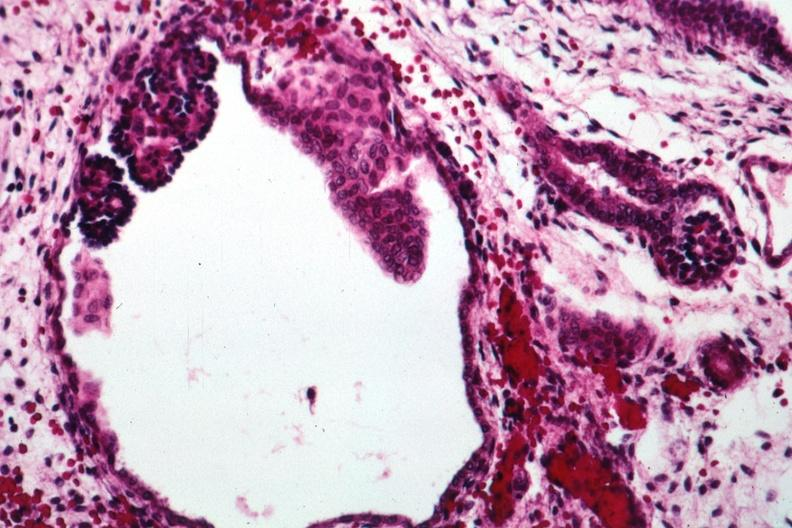s kidney present?
Answer the question using a single word or phrase. Yes 